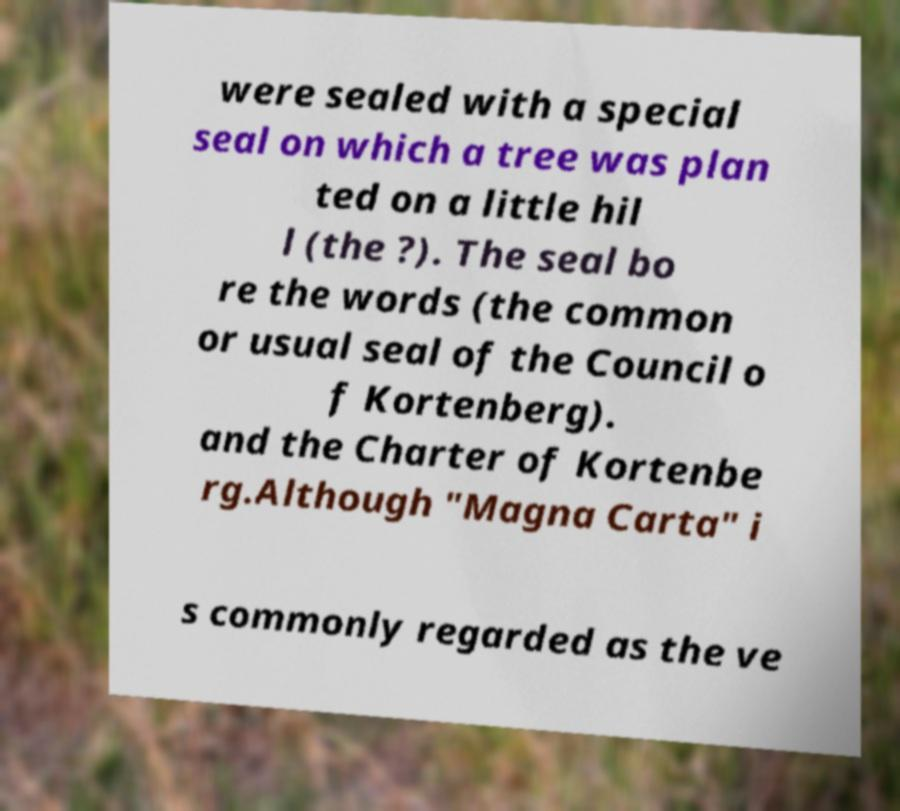Please read and relay the text visible in this image. What does it say? were sealed with a special seal on which a tree was plan ted on a little hil l (the ?). The seal bo re the words (the common or usual seal of the Council o f Kortenberg). and the Charter of Kortenbe rg.Although "Magna Carta" i s commonly regarded as the ve 